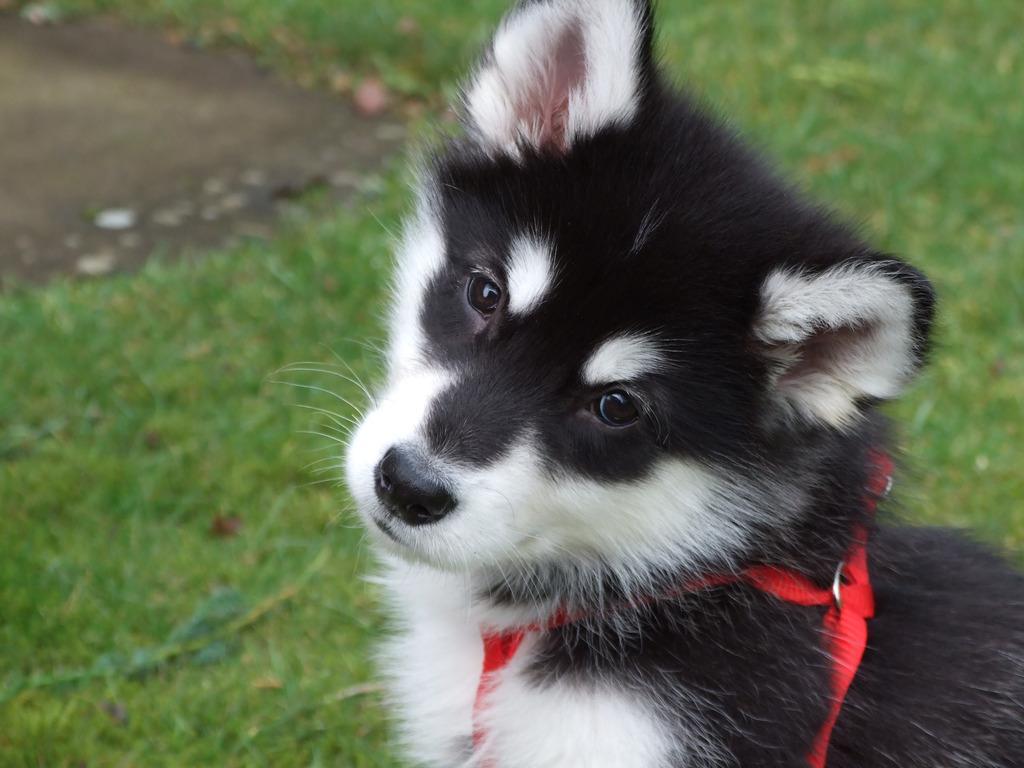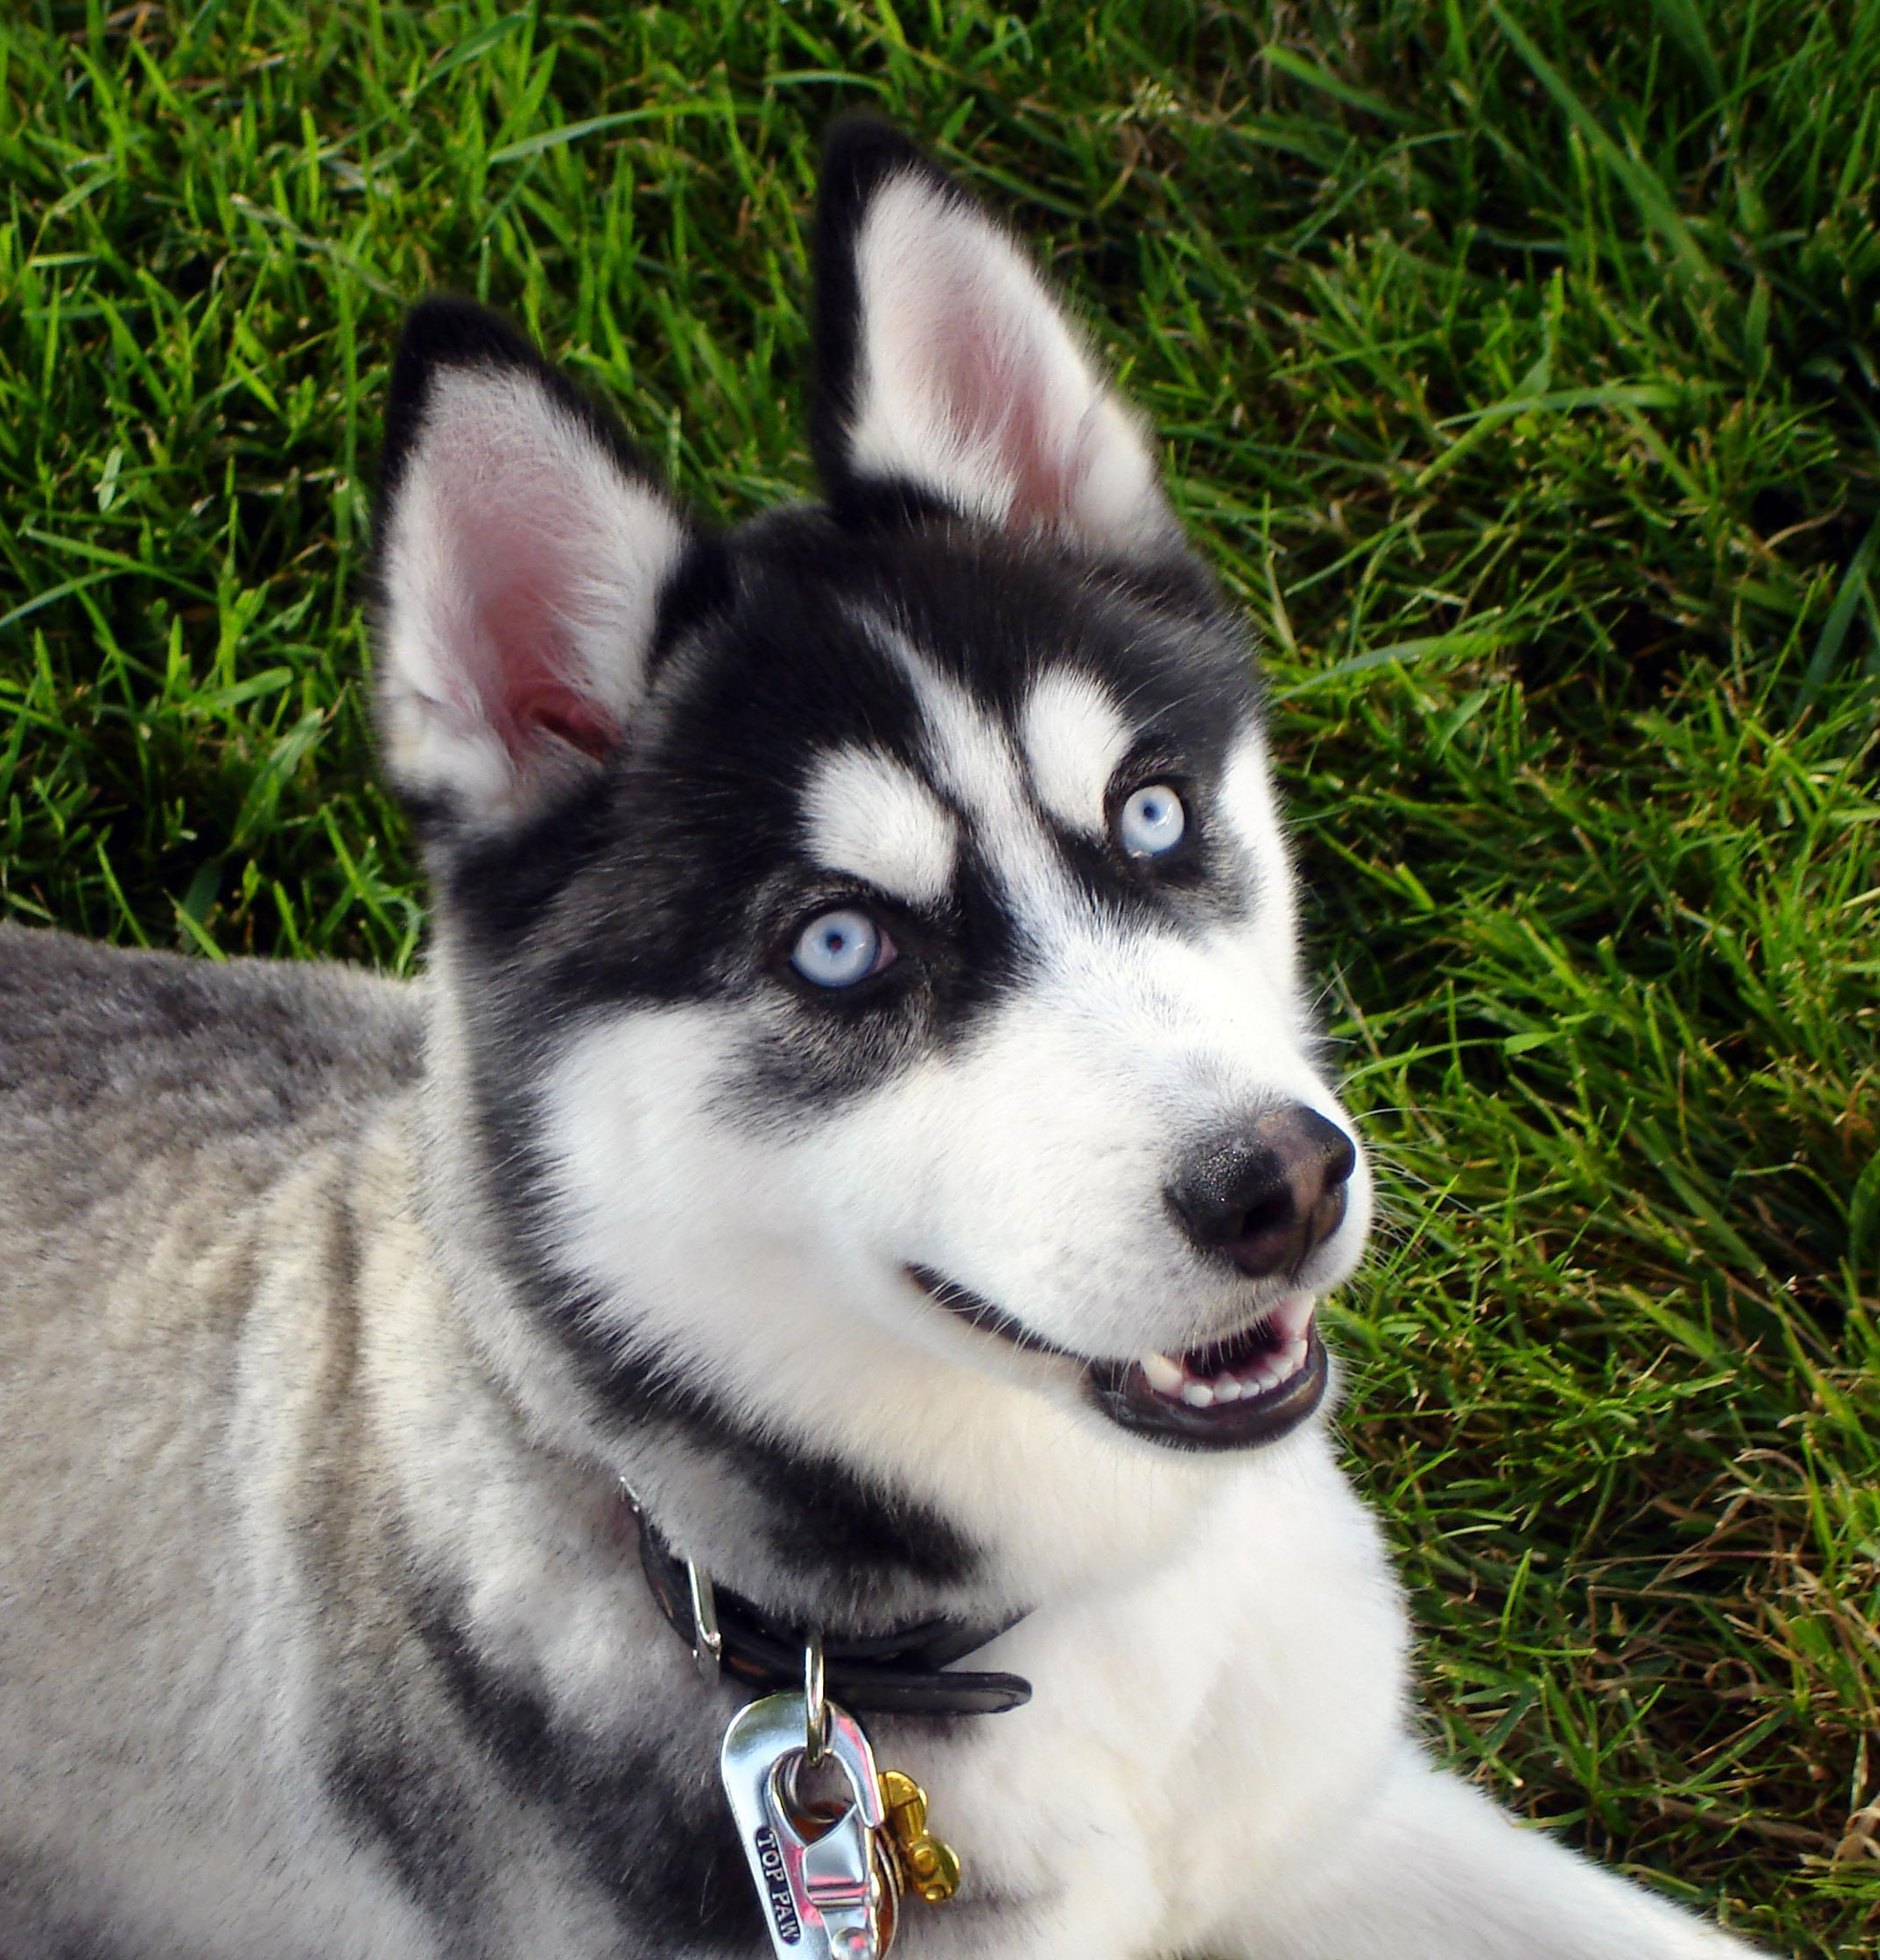The first image is the image on the left, the second image is the image on the right. Considering the images on both sides, is "One dog is laying down." valid? Answer yes or no. Yes. 